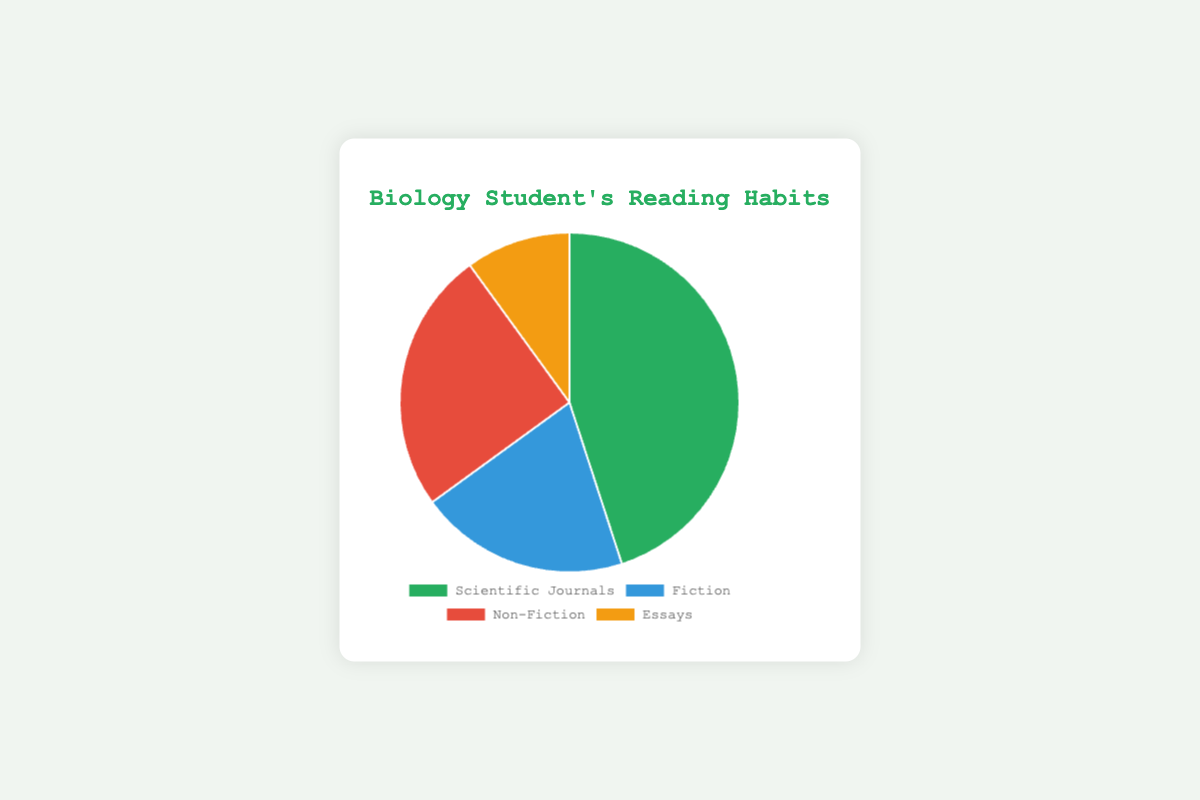Which genre does the biology student spend most of their time reading? The slice representing "Scientific Journals" covers the largest portion of the pie chart, which indicates the highest percentage.
Answer: Scientific Journals What percentage of the biology student's reading time is spent on non-scientific genres? The non-scientific genres here are Fiction, Non-Fiction, and Essays. Sum their percentages: 20 + 25 + 10 = 55%.
Answer: 55% Which genre occupies the smallest segment in the pie chart? The slice representing "Essays" is the smallest, so it has the lowest percentage.
Answer: Essays How does the time spent on Non-Fiction compare to the time spent on Fiction? The percentage of time spent on Non-Fiction is 25%, while on Fiction it is 20%. Non-Fiction is greater than Fiction by 5 percentage points.
Answer: Non-Fiction > Fiction by 5% What is the combined percentage of time spent on Scientific Journals and Essays? Sum the percentages of Scientific Journals and Essays: 45 + 10 = 55%.
Answer: 55% What is the difference in reading time between Scientific Journals and Non-Fiction? The percentage for Scientific Journals is 45%, for Non-Fiction it is 25%. The difference is 45 - 25 = 20 percentage points.
Answer: 20% Which genre's slice is visualized in red? The pie chart uses colors: green for Scientific Journals, blue for Fiction, red for Non-Fiction, and orange/yellow for Essays.
Answer: Non-Fiction If the student spent an equal amount of time on each genre instead, what would the percentage be for each? For four genres, if time is equal, each genre would occupy 100/4 = 25%.
Answer: 25% Which genres combined make up more than half of the reading time? The combined reading time of Scientific Journals (45%) and Non-Fiction (25%) is 45 + 25 = 70%, which is more than half.
Answer: Scientific Journals and Non-Fiction Between Fiction and Essays, which genre does the student spend more time on, and by how much? The time spent on Fiction is 20%, while on Essays is 10%. The student spends more time on Fiction by 20 - 10 = 10 percentage points.
Answer: Fiction by 10% 